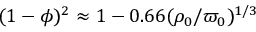<formula> <loc_0><loc_0><loc_500><loc_500>( 1 - \phi ) ^ { 2 } \approx 1 - 0 . 6 6 ( \rho _ { 0 } / \varpi _ { 0 } ) ^ { 1 / 3 }</formula> 